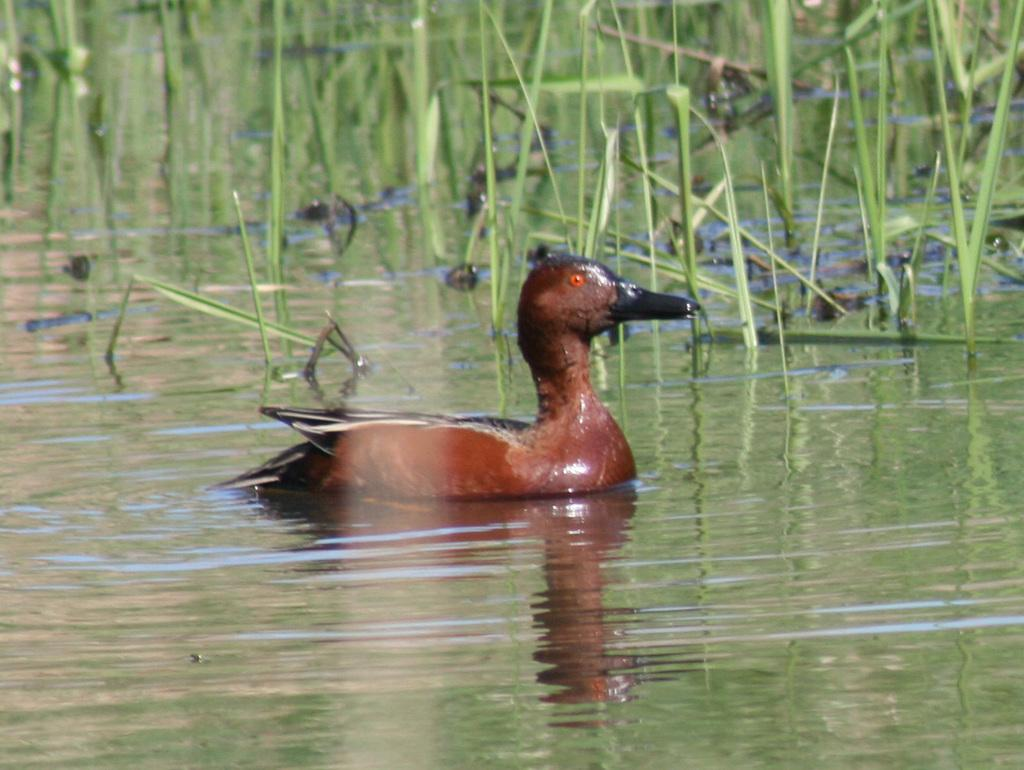What type of animal can be seen in the image? There is a bird in the image. Where is the bird located? The bird is in the water. What else can be seen in the image besides the bird? There are plants visible in the image. How many cents are visible on the bird's wing in the image? There are no cents visible on the bird's wing in the image, as the bird is a living creature and not a currency holder. 